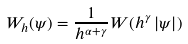Convert formula to latex. <formula><loc_0><loc_0><loc_500><loc_500>W _ { h } ( \psi ) = \frac { 1 } { h ^ { \alpha + \gamma } } W ( h ^ { \gamma } \left | \psi \right | )</formula> 